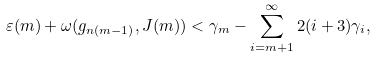Convert formula to latex. <formula><loc_0><loc_0><loc_500><loc_500>\varepsilon ( m ) + \omega ( g _ { n ( m - 1 ) } , J ( m ) ) < \gamma _ { m } - \sum _ { i = m + 1 } ^ { \infty } 2 ( i + 3 ) \gamma _ { i } ,</formula> 